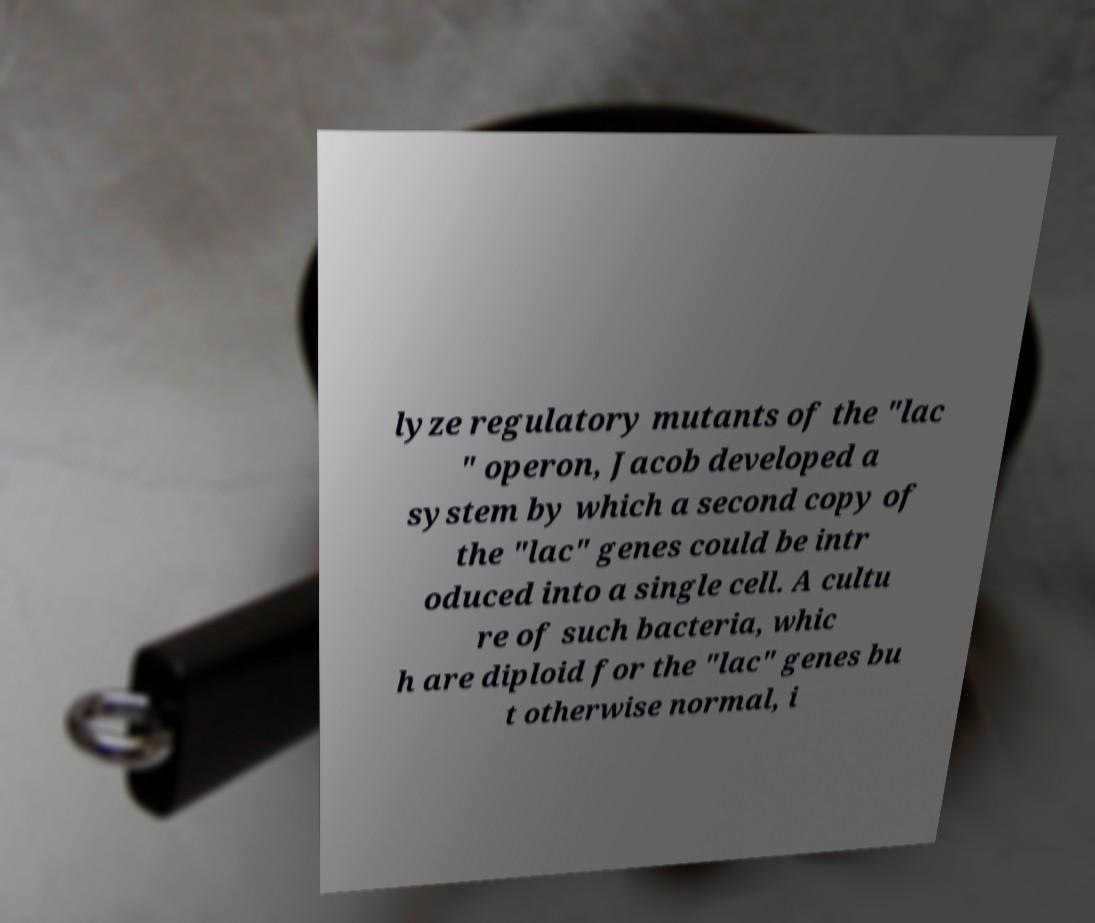Please read and relay the text visible in this image. What does it say? lyze regulatory mutants of the "lac " operon, Jacob developed a system by which a second copy of the "lac" genes could be intr oduced into a single cell. A cultu re of such bacteria, whic h are diploid for the "lac" genes bu t otherwise normal, i 